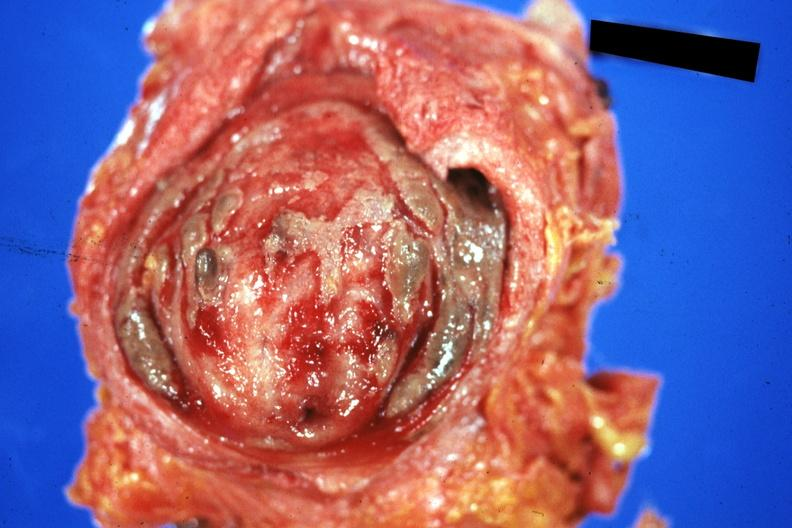where is this?
Answer the question using a single word or phrase. Urinary 